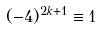Convert formula to latex. <formula><loc_0><loc_0><loc_500><loc_500>( - 4 ) ^ { 2 k + 1 } \equiv 1</formula> 